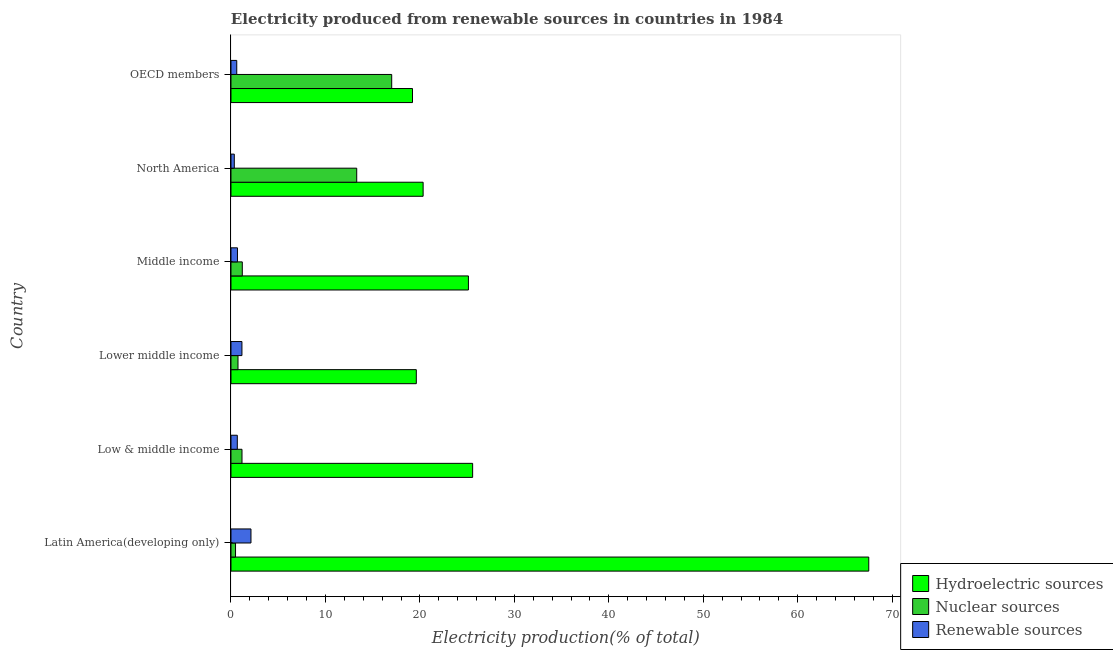How many different coloured bars are there?
Make the answer very short. 3. How many bars are there on the 6th tick from the top?
Your answer should be very brief. 3. How many bars are there on the 3rd tick from the bottom?
Keep it short and to the point. 3. What is the label of the 6th group of bars from the top?
Keep it short and to the point. Latin America(developing only). In how many cases, is the number of bars for a given country not equal to the number of legend labels?
Offer a very short reply. 0. What is the percentage of electricity produced by hydroelectric sources in North America?
Make the answer very short. 20.34. Across all countries, what is the maximum percentage of electricity produced by hydroelectric sources?
Your answer should be very brief. 67.52. Across all countries, what is the minimum percentage of electricity produced by hydroelectric sources?
Ensure brevity in your answer.  19.22. In which country was the percentage of electricity produced by hydroelectric sources maximum?
Keep it short and to the point. Latin America(developing only). In which country was the percentage of electricity produced by renewable sources minimum?
Provide a short and direct response. North America. What is the total percentage of electricity produced by renewable sources in the graph?
Your answer should be very brief. 5.6. What is the difference between the percentage of electricity produced by hydroelectric sources in Lower middle income and that in OECD members?
Your answer should be very brief. 0.4. What is the difference between the percentage of electricity produced by nuclear sources in Low & middle income and the percentage of electricity produced by renewable sources in Latin America(developing only)?
Your response must be concise. -0.95. What is the average percentage of electricity produced by renewable sources per country?
Offer a very short reply. 0.93. What is the difference between the percentage of electricity produced by hydroelectric sources and percentage of electricity produced by nuclear sources in Low & middle income?
Your answer should be compact. 24.42. In how many countries, is the percentage of electricity produced by nuclear sources greater than 54 %?
Offer a terse response. 0. What is the ratio of the percentage of electricity produced by hydroelectric sources in North America to that in OECD members?
Keep it short and to the point. 1.06. What is the difference between the highest and the second highest percentage of electricity produced by nuclear sources?
Provide a short and direct response. 3.7. What is the difference between the highest and the lowest percentage of electricity produced by renewable sources?
Make the answer very short. 1.76. In how many countries, is the percentage of electricity produced by renewable sources greater than the average percentage of electricity produced by renewable sources taken over all countries?
Give a very brief answer. 2. What does the 3rd bar from the top in Latin America(developing only) represents?
Keep it short and to the point. Hydroelectric sources. What does the 1st bar from the bottom in Lower middle income represents?
Offer a very short reply. Hydroelectric sources. How many bars are there?
Offer a very short reply. 18. Are all the bars in the graph horizontal?
Your answer should be compact. Yes. What is the difference between two consecutive major ticks on the X-axis?
Make the answer very short. 10. Are the values on the major ticks of X-axis written in scientific E-notation?
Your response must be concise. No. Where does the legend appear in the graph?
Offer a terse response. Bottom right. How many legend labels are there?
Offer a terse response. 3. How are the legend labels stacked?
Offer a terse response. Vertical. What is the title of the graph?
Make the answer very short. Electricity produced from renewable sources in countries in 1984. What is the Electricity production(% of total) of Hydroelectric sources in Latin America(developing only)?
Your answer should be compact. 67.52. What is the Electricity production(% of total) in Nuclear sources in Latin America(developing only)?
Give a very brief answer. 0.48. What is the Electricity production(% of total) in Renewable sources in Latin America(developing only)?
Make the answer very short. 2.12. What is the Electricity production(% of total) in Hydroelectric sources in Low & middle income?
Provide a succinct answer. 25.59. What is the Electricity production(% of total) of Nuclear sources in Low & middle income?
Provide a short and direct response. 1.17. What is the Electricity production(% of total) in Renewable sources in Low & middle income?
Keep it short and to the point. 0.67. What is the Electricity production(% of total) of Hydroelectric sources in Lower middle income?
Your response must be concise. 19.62. What is the Electricity production(% of total) in Nuclear sources in Lower middle income?
Provide a short and direct response. 0.74. What is the Electricity production(% of total) in Renewable sources in Lower middle income?
Provide a succinct answer. 1.16. What is the Electricity production(% of total) of Hydroelectric sources in Middle income?
Your answer should be compact. 25.14. What is the Electricity production(% of total) of Nuclear sources in Middle income?
Make the answer very short. 1.2. What is the Electricity production(% of total) in Renewable sources in Middle income?
Offer a terse response. 0.69. What is the Electricity production(% of total) of Hydroelectric sources in North America?
Give a very brief answer. 20.34. What is the Electricity production(% of total) in Nuclear sources in North America?
Keep it short and to the point. 13.31. What is the Electricity production(% of total) of Renewable sources in North America?
Your response must be concise. 0.35. What is the Electricity production(% of total) of Hydroelectric sources in OECD members?
Give a very brief answer. 19.22. What is the Electricity production(% of total) of Nuclear sources in OECD members?
Provide a succinct answer. 17.02. What is the Electricity production(% of total) of Renewable sources in OECD members?
Give a very brief answer. 0.61. Across all countries, what is the maximum Electricity production(% of total) in Hydroelectric sources?
Keep it short and to the point. 67.52. Across all countries, what is the maximum Electricity production(% of total) of Nuclear sources?
Keep it short and to the point. 17.02. Across all countries, what is the maximum Electricity production(% of total) in Renewable sources?
Keep it short and to the point. 2.12. Across all countries, what is the minimum Electricity production(% of total) of Hydroelectric sources?
Give a very brief answer. 19.22. Across all countries, what is the minimum Electricity production(% of total) of Nuclear sources?
Offer a terse response. 0.48. Across all countries, what is the minimum Electricity production(% of total) in Renewable sources?
Your answer should be very brief. 0.35. What is the total Electricity production(% of total) in Hydroelectric sources in the graph?
Make the answer very short. 177.43. What is the total Electricity production(% of total) of Nuclear sources in the graph?
Your response must be concise. 33.92. What is the total Electricity production(% of total) in Renewable sources in the graph?
Offer a terse response. 5.6. What is the difference between the Electricity production(% of total) in Hydroelectric sources in Latin America(developing only) and that in Low & middle income?
Ensure brevity in your answer.  41.94. What is the difference between the Electricity production(% of total) of Nuclear sources in Latin America(developing only) and that in Low & middle income?
Make the answer very short. -0.68. What is the difference between the Electricity production(% of total) of Renewable sources in Latin America(developing only) and that in Low & middle income?
Provide a succinct answer. 1.45. What is the difference between the Electricity production(% of total) of Hydroelectric sources in Latin America(developing only) and that in Lower middle income?
Keep it short and to the point. 47.9. What is the difference between the Electricity production(% of total) of Nuclear sources in Latin America(developing only) and that in Lower middle income?
Provide a succinct answer. -0.26. What is the difference between the Electricity production(% of total) in Renewable sources in Latin America(developing only) and that in Lower middle income?
Your answer should be compact. 0.96. What is the difference between the Electricity production(% of total) in Hydroelectric sources in Latin America(developing only) and that in Middle income?
Keep it short and to the point. 42.38. What is the difference between the Electricity production(% of total) in Nuclear sources in Latin America(developing only) and that in Middle income?
Ensure brevity in your answer.  -0.72. What is the difference between the Electricity production(% of total) in Renewable sources in Latin America(developing only) and that in Middle income?
Your answer should be compact. 1.43. What is the difference between the Electricity production(% of total) in Hydroelectric sources in Latin America(developing only) and that in North America?
Your answer should be compact. 47.18. What is the difference between the Electricity production(% of total) of Nuclear sources in Latin America(developing only) and that in North America?
Provide a succinct answer. -12.83. What is the difference between the Electricity production(% of total) of Renewable sources in Latin America(developing only) and that in North America?
Make the answer very short. 1.76. What is the difference between the Electricity production(% of total) in Hydroelectric sources in Latin America(developing only) and that in OECD members?
Your answer should be very brief. 48.3. What is the difference between the Electricity production(% of total) in Nuclear sources in Latin America(developing only) and that in OECD members?
Offer a very short reply. -16.53. What is the difference between the Electricity production(% of total) in Renewable sources in Latin America(developing only) and that in OECD members?
Give a very brief answer. 1.5. What is the difference between the Electricity production(% of total) of Hydroelectric sources in Low & middle income and that in Lower middle income?
Provide a succinct answer. 5.96. What is the difference between the Electricity production(% of total) in Nuclear sources in Low & middle income and that in Lower middle income?
Keep it short and to the point. 0.42. What is the difference between the Electricity production(% of total) in Renewable sources in Low & middle income and that in Lower middle income?
Your answer should be compact. -0.49. What is the difference between the Electricity production(% of total) in Hydroelectric sources in Low & middle income and that in Middle income?
Give a very brief answer. 0.45. What is the difference between the Electricity production(% of total) in Nuclear sources in Low & middle income and that in Middle income?
Provide a short and direct response. -0.03. What is the difference between the Electricity production(% of total) in Renewable sources in Low & middle income and that in Middle income?
Ensure brevity in your answer.  -0.02. What is the difference between the Electricity production(% of total) of Hydroelectric sources in Low & middle income and that in North America?
Offer a very short reply. 5.24. What is the difference between the Electricity production(% of total) in Nuclear sources in Low & middle income and that in North America?
Give a very brief answer. -12.15. What is the difference between the Electricity production(% of total) in Renewable sources in Low & middle income and that in North America?
Offer a very short reply. 0.32. What is the difference between the Electricity production(% of total) of Hydroelectric sources in Low & middle income and that in OECD members?
Your response must be concise. 6.37. What is the difference between the Electricity production(% of total) in Nuclear sources in Low & middle income and that in OECD members?
Your answer should be very brief. -15.85. What is the difference between the Electricity production(% of total) of Renewable sources in Low & middle income and that in OECD members?
Offer a terse response. 0.06. What is the difference between the Electricity production(% of total) of Hydroelectric sources in Lower middle income and that in Middle income?
Your answer should be very brief. -5.52. What is the difference between the Electricity production(% of total) of Nuclear sources in Lower middle income and that in Middle income?
Make the answer very short. -0.45. What is the difference between the Electricity production(% of total) in Renewable sources in Lower middle income and that in Middle income?
Offer a very short reply. 0.47. What is the difference between the Electricity production(% of total) in Hydroelectric sources in Lower middle income and that in North America?
Your response must be concise. -0.72. What is the difference between the Electricity production(% of total) in Nuclear sources in Lower middle income and that in North America?
Give a very brief answer. -12.57. What is the difference between the Electricity production(% of total) in Renewable sources in Lower middle income and that in North America?
Ensure brevity in your answer.  0.81. What is the difference between the Electricity production(% of total) in Hydroelectric sources in Lower middle income and that in OECD members?
Ensure brevity in your answer.  0.4. What is the difference between the Electricity production(% of total) in Nuclear sources in Lower middle income and that in OECD members?
Ensure brevity in your answer.  -16.27. What is the difference between the Electricity production(% of total) in Renewable sources in Lower middle income and that in OECD members?
Your answer should be compact. 0.55. What is the difference between the Electricity production(% of total) in Hydroelectric sources in Middle income and that in North America?
Provide a succinct answer. 4.8. What is the difference between the Electricity production(% of total) of Nuclear sources in Middle income and that in North America?
Give a very brief answer. -12.11. What is the difference between the Electricity production(% of total) in Renewable sources in Middle income and that in North America?
Offer a terse response. 0.34. What is the difference between the Electricity production(% of total) in Hydroelectric sources in Middle income and that in OECD members?
Offer a very short reply. 5.92. What is the difference between the Electricity production(% of total) in Nuclear sources in Middle income and that in OECD members?
Offer a very short reply. -15.82. What is the difference between the Electricity production(% of total) in Renewable sources in Middle income and that in OECD members?
Your answer should be very brief. 0.08. What is the difference between the Electricity production(% of total) in Hydroelectric sources in North America and that in OECD members?
Your response must be concise. 1.12. What is the difference between the Electricity production(% of total) in Nuclear sources in North America and that in OECD members?
Your answer should be very brief. -3.7. What is the difference between the Electricity production(% of total) of Renewable sources in North America and that in OECD members?
Ensure brevity in your answer.  -0.26. What is the difference between the Electricity production(% of total) of Hydroelectric sources in Latin America(developing only) and the Electricity production(% of total) of Nuclear sources in Low & middle income?
Make the answer very short. 66.36. What is the difference between the Electricity production(% of total) of Hydroelectric sources in Latin America(developing only) and the Electricity production(% of total) of Renewable sources in Low & middle income?
Your answer should be very brief. 66.85. What is the difference between the Electricity production(% of total) in Nuclear sources in Latin America(developing only) and the Electricity production(% of total) in Renewable sources in Low & middle income?
Keep it short and to the point. -0.19. What is the difference between the Electricity production(% of total) in Hydroelectric sources in Latin America(developing only) and the Electricity production(% of total) in Nuclear sources in Lower middle income?
Make the answer very short. 66.78. What is the difference between the Electricity production(% of total) in Hydroelectric sources in Latin America(developing only) and the Electricity production(% of total) in Renewable sources in Lower middle income?
Provide a short and direct response. 66.36. What is the difference between the Electricity production(% of total) in Nuclear sources in Latin America(developing only) and the Electricity production(% of total) in Renewable sources in Lower middle income?
Offer a very short reply. -0.68. What is the difference between the Electricity production(% of total) of Hydroelectric sources in Latin America(developing only) and the Electricity production(% of total) of Nuclear sources in Middle income?
Offer a terse response. 66.32. What is the difference between the Electricity production(% of total) of Hydroelectric sources in Latin America(developing only) and the Electricity production(% of total) of Renewable sources in Middle income?
Your answer should be very brief. 66.84. What is the difference between the Electricity production(% of total) of Nuclear sources in Latin America(developing only) and the Electricity production(% of total) of Renewable sources in Middle income?
Keep it short and to the point. -0.2. What is the difference between the Electricity production(% of total) of Hydroelectric sources in Latin America(developing only) and the Electricity production(% of total) of Nuclear sources in North America?
Make the answer very short. 54.21. What is the difference between the Electricity production(% of total) of Hydroelectric sources in Latin America(developing only) and the Electricity production(% of total) of Renewable sources in North America?
Provide a succinct answer. 67.17. What is the difference between the Electricity production(% of total) of Nuclear sources in Latin America(developing only) and the Electricity production(% of total) of Renewable sources in North America?
Give a very brief answer. 0.13. What is the difference between the Electricity production(% of total) in Hydroelectric sources in Latin America(developing only) and the Electricity production(% of total) in Nuclear sources in OECD members?
Offer a terse response. 50.51. What is the difference between the Electricity production(% of total) in Hydroelectric sources in Latin America(developing only) and the Electricity production(% of total) in Renewable sources in OECD members?
Make the answer very short. 66.91. What is the difference between the Electricity production(% of total) of Nuclear sources in Latin America(developing only) and the Electricity production(% of total) of Renewable sources in OECD members?
Your response must be concise. -0.13. What is the difference between the Electricity production(% of total) of Hydroelectric sources in Low & middle income and the Electricity production(% of total) of Nuclear sources in Lower middle income?
Your response must be concise. 24.84. What is the difference between the Electricity production(% of total) in Hydroelectric sources in Low & middle income and the Electricity production(% of total) in Renewable sources in Lower middle income?
Provide a succinct answer. 24.43. What is the difference between the Electricity production(% of total) of Nuclear sources in Low & middle income and the Electricity production(% of total) of Renewable sources in Lower middle income?
Make the answer very short. 0.01. What is the difference between the Electricity production(% of total) of Hydroelectric sources in Low & middle income and the Electricity production(% of total) of Nuclear sources in Middle income?
Provide a succinct answer. 24.39. What is the difference between the Electricity production(% of total) of Hydroelectric sources in Low & middle income and the Electricity production(% of total) of Renewable sources in Middle income?
Your answer should be compact. 24.9. What is the difference between the Electricity production(% of total) of Nuclear sources in Low & middle income and the Electricity production(% of total) of Renewable sources in Middle income?
Offer a terse response. 0.48. What is the difference between the Electricity production(% of total) of Hydroelectric sources in Low & middle income and the Electricity production(% of total) of Nuclear sources in North America?
Make the answer very short. 12.27. What is the difference between the Electricity production(% of total) of Hydroelectric sources in Low & middle income and the Electricity production(% of total) of Renewable sources in North America?
Your response must be concise. 25.23. What is the difference between the Electricity production(% of total) in Nuclear sources in Low & middle income and the Electricity production(% of total) in Renewable sources in North America?
Your response must be concise. 0.81. What is the difference between the Electricity production(% of total) in Hydroelectric sources in Low & middle income and the Electricity production(% of total) in Nuclear sources in OECD members?
Make the answer very short. 8.57. What is the difference between the Electricity production(% of total) of Hydroelectric sources in Low & middle income and the Electricity production(% of total) of Renewable sources in OECD members?
Your answer should be very brief. 24.97. What is the difference between the Electricity production(% of total) of Nuclear sources in Low & middle income and the Electricity production(% of total) of Renewable sources in OECD members?
Your response must be concise. 0.56. What is the difference between the Electricity production(% of total) in Hydroelectric sources in Lower middle income and the Electricity production(% of total) in Nuclear sources in Middle income?
Ensure brevity in your answer.  18.42. What is the difference between the Electricity production(% of total) of Hydroelectric sources in Lower middle income and the Electricity production(% of total) of Renewable sources in Middle income?
Provide a short and direct response. 18.93. What is the difference between the Electricity production(% of total) in Nuclear sources in Lower middle income and the Electricity production(% of total) in Renewable sources in Middle income?
Make the answer very short. 0.06. What is the difference between the Electricity production(% of total) in Hydroelectric sources in Lower middle income and the Electricity production(% of total) in Nuclear sources in North America?
Your response must be concise. 6.31. What is the difference between the Electricity production(% of total) in Hydroelectric sources in Lower middle income and the Electricity production(% of total) in Renewable sources in North America?
Your answer should be very brief. 19.27. What is the difference between the Electricity production(% of total) of Nuclear sources in Lower middle income and the Electricity production(% of total) of Renewable sources in North America?
Provide a short and direct response. 0.39. What is the difference between the Electricity production(% of total) of Hydroelectric sources in Lower middle income and the Electricity production(% of total) of Nuclear sources in OECD members?
Offer a very short reply. 2.6. What is the difference between the Electricity production(% of total) in Hydroelectric sources in Lower middle income and the Electricity production(% of total) in Renewable sources in OECD members?
Give a very brief answer. 19.01. What is the difference between the Electricity production(% of total) of Nuclear sources in Lower middle income and the Electricity production(% of total) of Renewable sources in OECD members?
Keep it short and to the point. 0.13. What is the difference between the Electricity production(% of total) of Hydroelectric sources in Middle income and the Electricity production(% of total) of Nuclear sources in North America?
Provide a succinct answer. 11.83. What is the difference between the Electricity production(% of total) in Hydroelectric sources in Middle income and the Electricity production(% of total) in Renewable sources in North America?
Keep it short and to the point. 24.79. What is the difference between the Electricity production(% of total) in Nuclear sources in Middle income and the Electricity production(% of total) in Renewable sources in North America?
Provide a short and direct response. 0.85. What is the difference between the Electricity production(% of total) in Hydroelectric sources in Middle income and the Electricity production(% of total) in Nuclear sources in OECD members?
Make the answer very short. 8.12. What is the difference between the Electricity production(% of total) of Hydroelectric sources in Middle income and the Electricity production(% of total) of Renewable sources in OECD members?
Your response must be concise. 24.53. What is the difference between the Electricity production(% of total) of Nuclear sources in Middle income and the Electricity production(% of total) of Renewable sources in OECD members?
Make the answer very short. 0.59. What is the difference between the Electricity production(% of total) in Hydroelectric sources in North America and the Electricity production(% of total) in Nuclear sources in OECD members?
Offer a terse response. 3.33. What is the difference between the Electricity production(% of total) of Hydroelectric sources in North America and the Electricity production(% of total) of Renewable sources in OECD members?
Provide a short and direct response. 19.73. What is the difference between the Electricity production(% of total) in Nuclear sources in North America and the Electricity production(% of total) in Renewable sources in OECD members?
Your response must be concise. 12.7. What is the average Electricity production(% of total) of Hydroelectric sources per country?
Make the answer very short. 29.57. What is the average Electricity production(% of total) of Nuclear sources per country?
Ensure brevity in your answer.  5.65. What is the average Electricity production(% of total) of Renewable sources per country?
Offer a terse response. 0.93. What is the difference between the Electricity production(% of total) of Hydroelectric sources and Electricity production(% of total) of Nuclear sources in Latin America(developing only)?
Keep it short and to the point. 67.04. What is the difference between the Electricity production(% of total) of Hydroelectric sources and Electricity production(% of total) of Renewable sources in Latin America(developing only)?
Offer a terse response. 65.41. What is the difference between the Electricity production(% of total) of Nuclear sources and Electricity production(% of total) of Renewable sources in Latin America(developing only)?
Provide a succinct answer. -1.63. What is the difference between the Electricity production(% of total) of Hydroelectric sources and Electricity production(% of total) of Nuclear sources in Low & middle income?
Your response must be concise. 24.42. What is the difference between the Electricity production(% of total) in Hydroelectric sources and Electricity production(% of total) in Renewable sources in Low & middle income?
Provide a succinct answer. 24.92. What is the difference between the Electricity production(% of total) in Nuclear sources and Electricity production(% of total) in Renewable sources in Low & middle income?
Provide a short and direct response. 0.5. What is the difference between the Electricity production(% of total) in Hydroelectric sources and Electricity production(% of total) in Nuclear sources in Lower middle income?
Provide a short and direct response. 18.88. What is the difference between the Electricity production(% of total) of Hydroelectric sources and Electricity production(% of total) of Renewable sources in Lower middle income?
Ensure brevity in your answer.  18.46. What is the difference between the Electricity production(% of total) in Nuclear sources and Electricity production(% of total) in Renewable sources in Lower middle income?
Keep it short and to the point. -0.42. What is the difference between the Electricity production(% of total) in Hydroelectric sources and Electricity production(% of total) in Nuclear sources in Middle income?
Your response must be concise. 23.94. What is the difference between the Electricity production(% of total) in Hydroelectric sources and Electricity production(% of total) in Renewable sources in Middle income?
Ensure brevity in your answer.  24.45. What is the difference between the Electricity production(% of total) in Nuclear sources and Electricity production(% of total) in Renewable sources in Middle income?
Your response must be concise. 0.51. What is the difference between the Electricity production(% of total) in Hydroelectric sources and Electricity production(% of total) in Nuclear sources in North America?
Offer a very short reply. 7.03. What is the difference between the Electricity production(% of total) of Hydroelectric sources and Electricity production(% of total) of Renewable sources in North America?
Provide a succinct answer. 19.99. What is the difference between the Electricity production(% of total) of Nuclear sources and Electricity production(% of total) of Renewable sources in North America?
Your answer should be compact. 12.96. What is the difference between the Electricity production(% of total) of Hydroelectric sources and Electricity production(% of total) of Nuclear sources in OECD members?
Keep it short and to the point. 2.2. What is the difference between the Electricity production(% of total) of Hydroelectric sources and Electricity production(% of total) of Renewable sources in OECD members?
Your answer should be compact. 18.61. What is the difference between the Electricity production(% of total) of Nuclear sources and Electricity production(% of total) of Renewable sources in OECD members?
Your response must be concise. 16.4. What is the ratio of the Electricity production(% of total) in Hydroelectric sources in Latin America(developing only) to that in Low & middle income?
Ensure brevity in your answer.  2.64. What is the ratio of the Electricity production(% of total) in Nuclear sources in Latin America(developing only) to that in Low & middle income?
Provide a succinct answer. 0.41. What is the ratio of the Electricity production(% of total) in Renewable sources in Latin America(developing only) to that in Low & middle income?
Your response must be concise. 3.16. What is the ratio of the Electricity production(% of total) in Hydroelectric sources in Latin America(developing only) to that in Lower middle income?
Provide a succinct answer. 3.44. What is the ratio of the Electricity production(% of total) in Nuclear sources in Latin America(developing only) to that in Lower middle income?
Give a very brief answer. 0.65. What is the ratio of the Electricity production(% of total) in Renewable sources in Latin America(developing only) to that in Lower middle income?
Keep it short and to the point. 1.82. What is the ratio of the Electricity production(% of total) of Hydroelectric sources in Latin America(developing only) to that in Middle income?
Your response must be concise. 2.69. What is the ratio of the Electricity production(% of total) in Nuclear sources in Latin America(developing only) to that in Middle income?
Make the answer very short. 0.4. What is the ratio of the Electricity production(% of total) in Renewable sources in Latin America(developing only) to that in Middle income?
Give a very brief answer. 3.08. What is the ratio of the Electricity production(% of total) in Hydroelectric sources in Latin America(developing only) to that in North America?
Provide a short and direct response. 3.32. What is the ratio of the Electricity production(% of total) in Nuclear sources in Latin America(developing only) to that in North America?
Provide a succinct answer. 0.04. What is the ratio of the Electricity production(% of total) of Renewable sources in Latin America(developing only) to that in North America?
Provide a succinct answer. 6.01. What is the ratio of the Electricity production(% of total) of Hydroelectric sources in Latin America(developing only) to that in OECD members?
Your answer should be very brief. 3.51. What is the ratio of the Electricity production(% of total) of Nuclear sources in Latin America(developing only) to that in OECD members?
Your answer should be very brief. 0.03. What is the ratio of the Electricity production(% of total) of Renewable sources in Latin America(developing only) to that in OECD members?
Your answer should be compact. 3.46. What is the ratio of the Electricity production(% of total) in Hydroelectric sources in Low & middle income to that in Lower middle income?
Keep it short and to the point. 1.3. What is the ratio of the Electricity production(% of total) of Nuclear sources in Low & middle income to that in Lower middle income?
Make the answer very short. 1.57. What is the ratio of the Electricity production(% of total) of Renewable sources in Low & middle income to that in Lower middle income?
Provide a short and direct response. 0.58. What is the ratio of the Electricity production(% of total) of Hydroelectric sources in Low & middle income to that in Middle income?
Keep it short and to the point. 1.02. What is the ratio of the Electricity production(% of total) of Nuclear sources in Low & middle income to that in Middle income?
Provide a succinct answer. 0.97. What is the ratio of the Electricity production(% of total) in Renewable sources in Low & middle income to that in Middle income?
Your answer should be compact. 0.98. What is the ratio of the Electricity production(% of total) of Hydroelectric sources in Low & middle income to that in North America?
Make the answer very short. 1.26. What is the ratio of the Electricity production(% of total) in Nuclear sources in Low & middle income to that in North America?
Provide a succinct answer. 0.09. What is the ratio of the Electricity production(% of total) of Renewable sources in Low & middle income to that in North America?
Ensure brevity in your answer.  1.9. What is the ratio of the Electricity production(% of total) in Hydroelectric sources in Low & middle income to that in OECD members?
Provide a short and direct response. 1.33. What is the ratio of the Electricity production(% of total) of Nuclear sources in Low & middle income to that in OECD members?
Your answer should be compact. 0.07. What is the ratio of the Electricity production(% of total) of Renewable sources in Low & middle income to that in OECD members?
Give a very brief answer. 1.1. What is the ratio of the Electricity production(% of total) in Hydroelectric sources in Lower middle income to that in Middle income?
Offer a very short reply. 0.78. What is the ratio of the Electricity production(% of total) in Nuclear sources in Lower middle income to that in Middle income?
Provide a succinct answer. 0.62. What is the ratio of the Electricity production(% of total) of Renewable sources in Lower middle income to that in Middle income?
Offer a very short reply. 1.69. What is the ratio of the Electricity production(% of total) of Hydroelectric sources in Lower middle income to that in North America?
Offer a terse response. 0.96. What is the ratio of the Electricity production(% of total) of Nuclear sources in Lower middle income to that in North America?
Provide a short and direct response. 0.06. What is the ratio of the Electricity production(% of total) in Renewable sources in Lower middle income to that in North America?
Ensure brevity in your answer.  3.3. What is the ratio of the Electricity production(% of total) in Hydroelectric sources in Lower middle income to that in OECD members?
Provide a short and direct response. 1.02. What is the ratio of the Electricity production(% of total) in Nuclear sources in Lower middle income to that in OECD members?
Make the answer very short. 0.04. What is the ratio of the Electricity production(% of total) of Renewable sources in Lower middle income to that in OECD members?
Ensure brevity in your answer.  1.9. What is the ratio of the Electricity production(% of total) in Hydroelectric sources in Middle income to that in North America?
Keep it short and to the point. 1.24. What is the ratio of the Electricity production(% of total) of Nuclear sources in Middle income to that in North America?
Offer a very short reply. 0.09. What is the ratio of the Electricity production(% of total) in Renewable sources in Middle income to that in North America?
Keep it short and to the point. 1.95. What is the ratio of the Electricity production(% of total) in Hydroelectric sources in Middle income to that in OECD members?
Make the answer very short. 1.31. What is the ratio of the Electricity production(% of total) in Nuclear sources in Middle income to that in OECD members?
Ensure brevity in your answer.  0.07. What is the ratio of the Electricity production(% of total) in Renewable sources in Middle income to that in OECD members?
Provide a short and direct response. 1.12. What is the ratio of the Electricity production(% of total) in Hydroelectric sources in North America to that in OECD members?
Keep it short and to the point. 1.06. What is the ratio of the Electricity production(% of total) in Nuclear sources in North America to that in OECD members?
Your response must be concise. 0.78. What is the ratio of the Electricity production(% of total) of Renewable sources in North America to that in OECD members?
Provide a succinct answer. 0.58. What is the difference between the highest and the second highest Electricity production(% of total) of Hydroelectric sources?
Offer a terse response. 41.94. What is the difference between the highest and the second highest Electricity production(% of total) in Nuclear sources?
Ensure brevity in your answer.  3.7. What is the difference between the highest and the second highest Electricity production(% of total) in Renewable sources?
Give a very brief answer. 0.96. What is the difference between the highest and the lowest Electricity production(% of total) in Hydroelectric sources?
Offer a terse response. 48.3. What is the difference between the highest and the lowest Electricity production(% of total) of Nuclear sources?
Your answer should be compact. 16.53. What is the difference between the highest and the lowest Electricity production(% of total) of Renewable sources?
Your response must be concise. 1.76. 